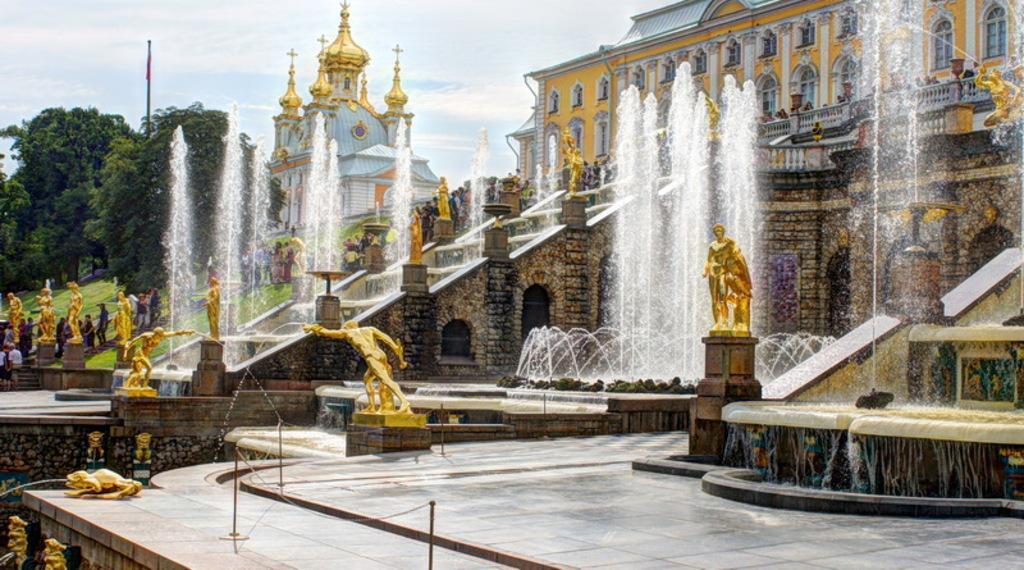Describe this image in one or two sentences. In this picture we can see sculptures, water fountains, poles, walls and steps. There are people and we can see grass, buildings, railing and trees. In the background of the image we can see the sky with clouds. 